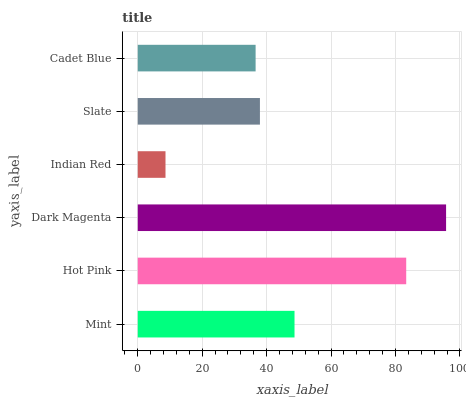Is Indian Red the minimum?
Answer yes or no. Yes. Is Dark Magenta the maximum?
Answer yes or no. Yes. Is Hot Pink the minimum?
Answer yes or no. No. Is Hot Pink the maximum?
Answer yes or no. No. Is Hot Pink greater than Mint?
Answer yes or no. Yes. Is Mint less than Hot Pink?
Answer yes or no. Yes. Is Mint greater than Hot Pink?
Answer yes or no. No. Is Hot Pink less than Mint?
Answer yes or no. No. Is Mint the high median?
Answer yes or no. Yes. Is Slate the low median?
Answer yes or no. Yes. Is Indian Red the high median?
Answer yes or no. No. Is Mint the low median?
Answer yes or no. No. 